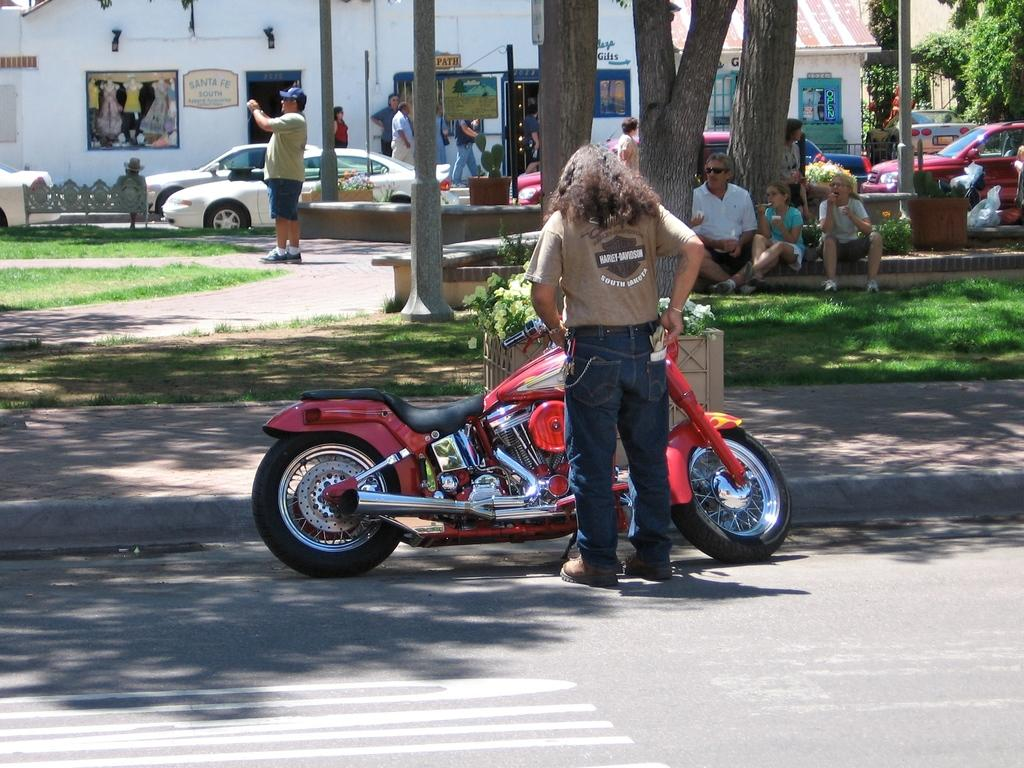What is the person in the image doing? The person is standing on the road. What object is in front of the person? There is a bike in front of the person. What can be seen in the background of the image? There are people, vehicles, buildings, and trees in the background of the image. What type of sheet is being used to cover the account in the image? There is no sheet or account present in the image. 